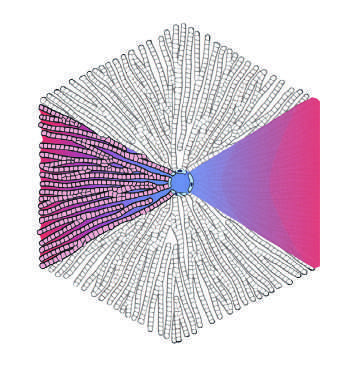what are at the periphery?
Answer the question using a single word or phrase. Portal tracts 